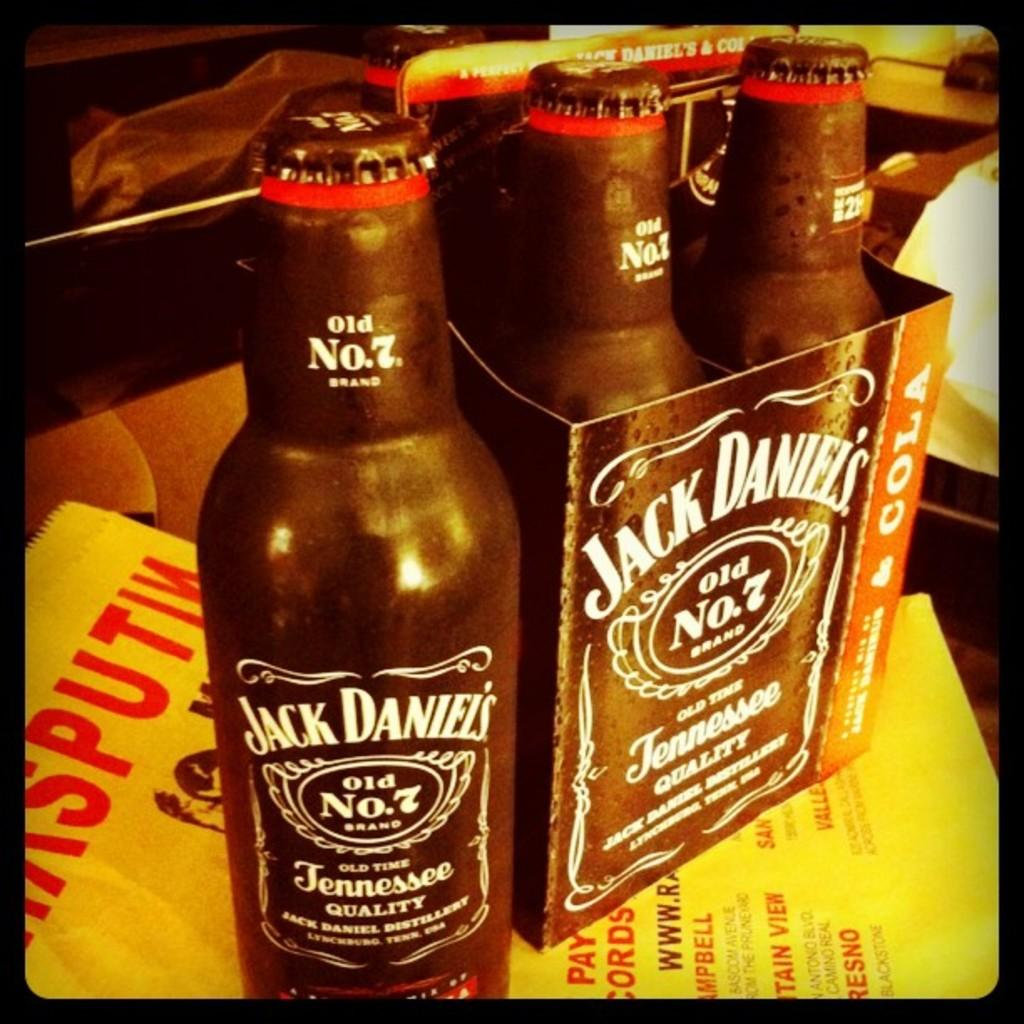What objects are present in the image that contain text? There are bottles and a yellow paper in the image that have text written on them. Can you describe the appearance of the bottles? The bottles have text written on them. What color is the paper in the image? The paper in the image is yellow. What is written on the yellow paper? The yellow paper has text written on it. How many girls are playing the guitar in the image? There are no girls or guitars present in the image. What role does the father play in the image? There is no father or indication of a familial relationship in the image. 